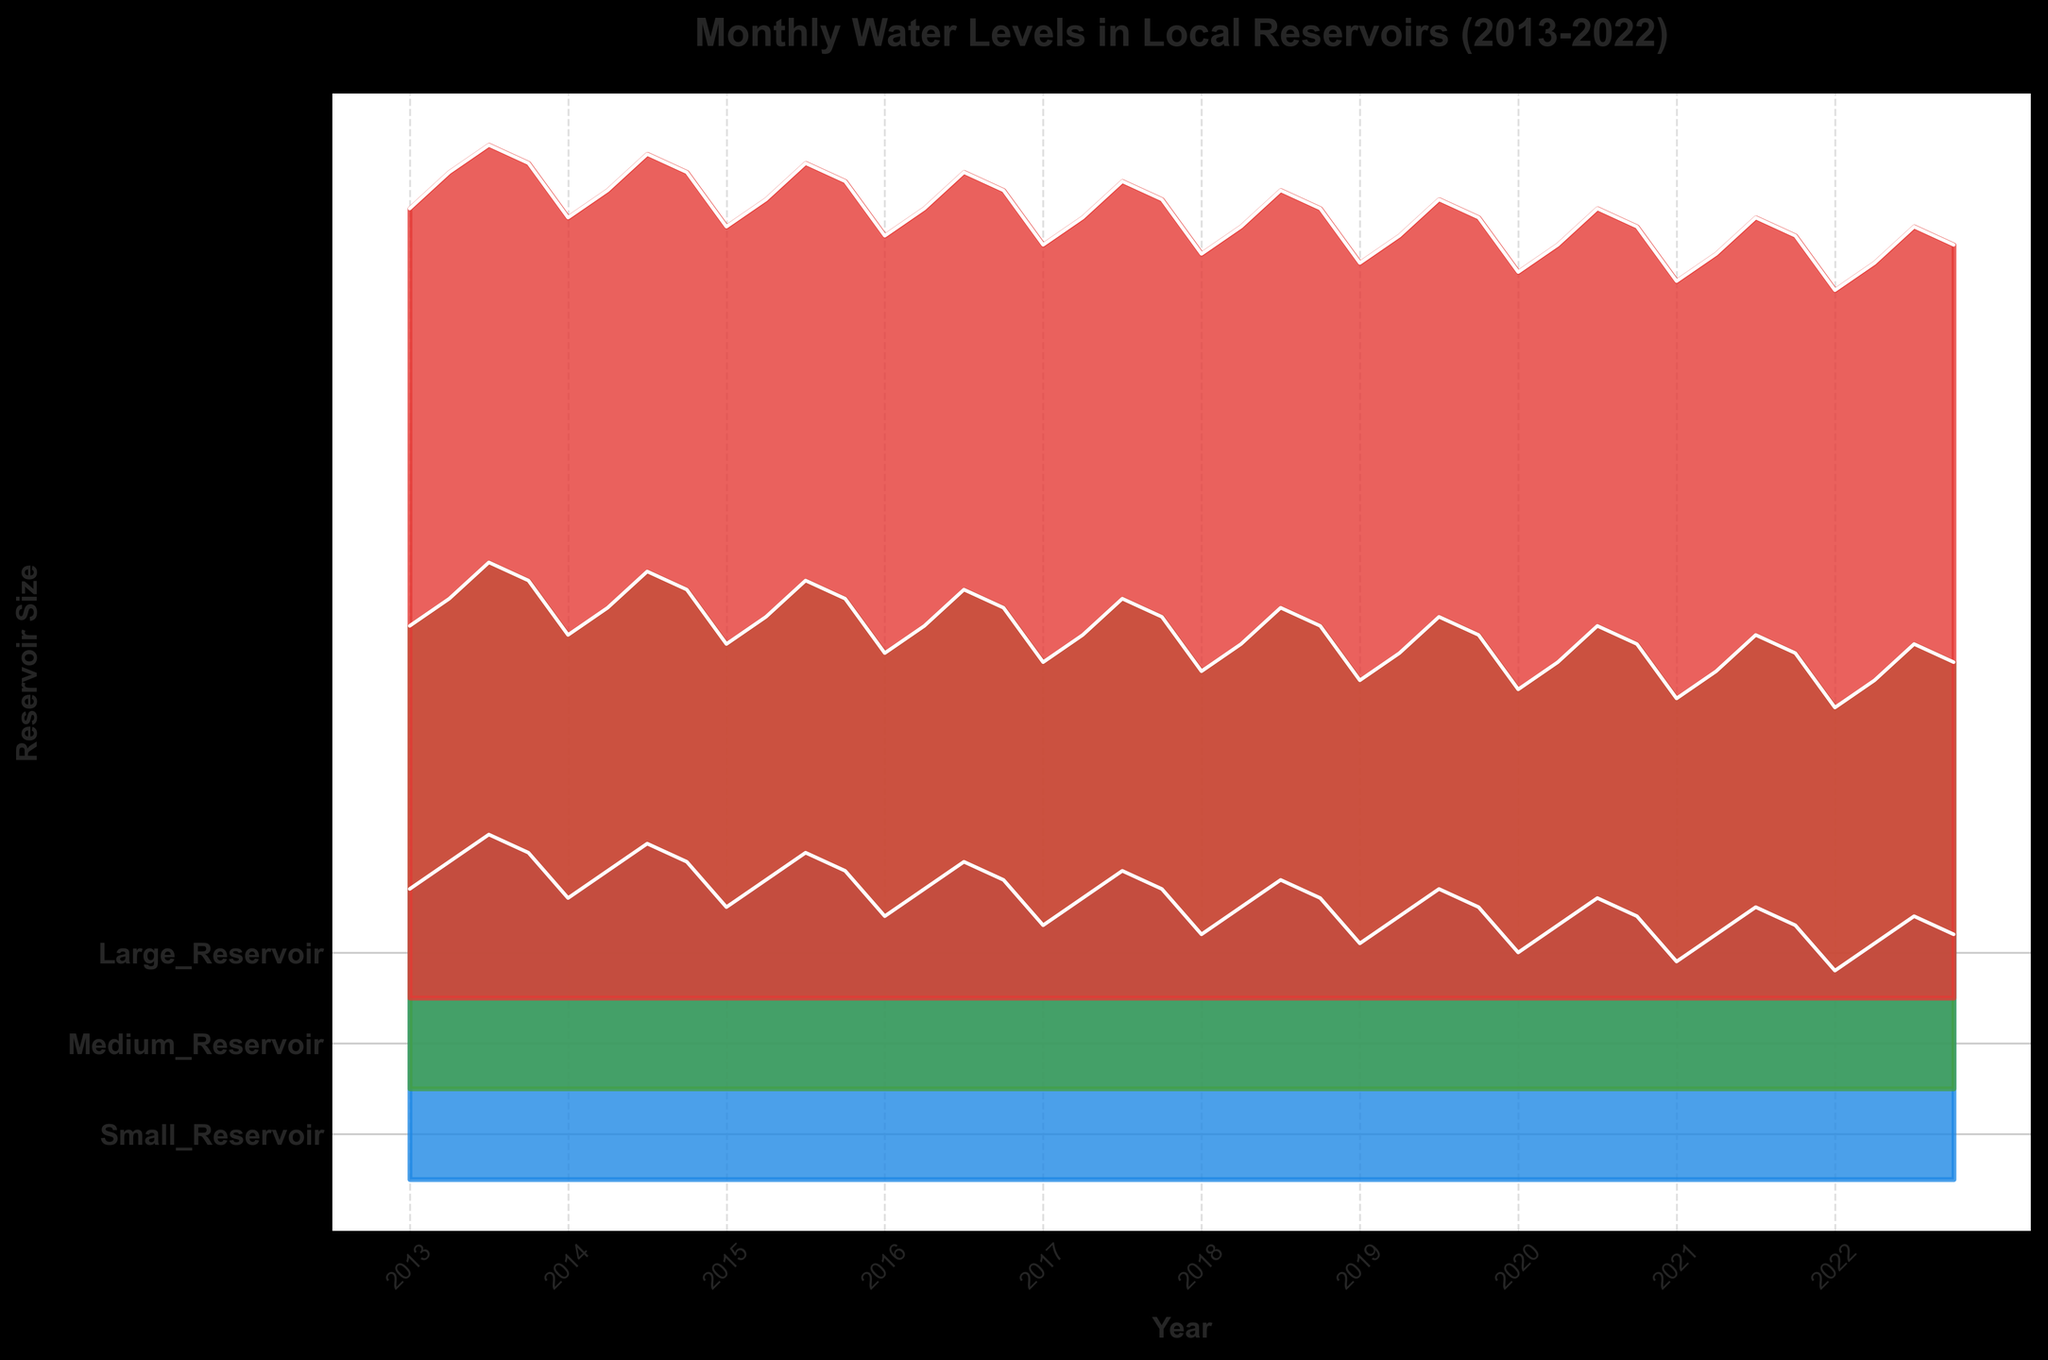What is the title of the plot? The title is usually placed at the top of the plot. According to the description, it is "Monthly Water Levels in Local Reservoirs (2013-2022)"
Answer: Monthly Water Levels in Local Reservoirs (2013-2022) Which month and year had the highest water level for Large Reservoirs? From the ridgeline plot, we look for the peak in the Large Reservoirs category. The highest peak appears in July 2013.
Answer: July 2013 How does the water level in Small Reservoirs in January 2016 compare to that in January 2018? We observe the ridgeline for Small Reservoirs. The water level in January 2016 is lower compared to January 2018. This is evident from the lower position in the plot.
Answer: Lower in January 2016 What is the general trend for Medium Reservoirs from 2013 to 2022? The ridgeline plot shows a gradual decrease in the water levels of Medium Reservoirs from 2013 to 2022, indicating a declining trend over this period.
Answer: Declining trend Which reservoir size category saw the most fluctuation in water levels? By observing the variability and range in the heights of the ridgelines, Large Reservoirs show the most fluctuation in water levels over the decade.
Answer: Large Reservoirs How do the water levels in April 2020 for Medium and Large Reservoirs compare? We compare the peaks of the Medium and Large Reservoirs ridgelines in April 2020. The peak for Large Reservoirs is higher than that of Medium Reservoirs.
Answer: Higher in Large Reservoirs During which years did Small Reservoirs have water levels consistently below 3 units? By looking at the Small Reservoir ridgeline, the years where the water levels consistently stayed below 3 are 2019, 2020, 2021, and 2022.
Answer: 2019 to 2022 What is the difference in the water levels between Large and Small Reservoirs in July 2015? Locate the peaks for both Large and Small Reservoirs in July 2015 in the ridgeline plot. Large Reservoirs have a peak at 9.2 units, and Small Reservoirs have a peak at 3.6 units. The difference is 9.2 - 3.6 = 5.6 units.
Answer: 5.6 units In which year did Medium Reservoirs have their highest water level in October? From the ridgeline plot, we observe the peaks for Medium Reservoirs in October of each year. The highest peak is in October 2013.
Answer: 2013 